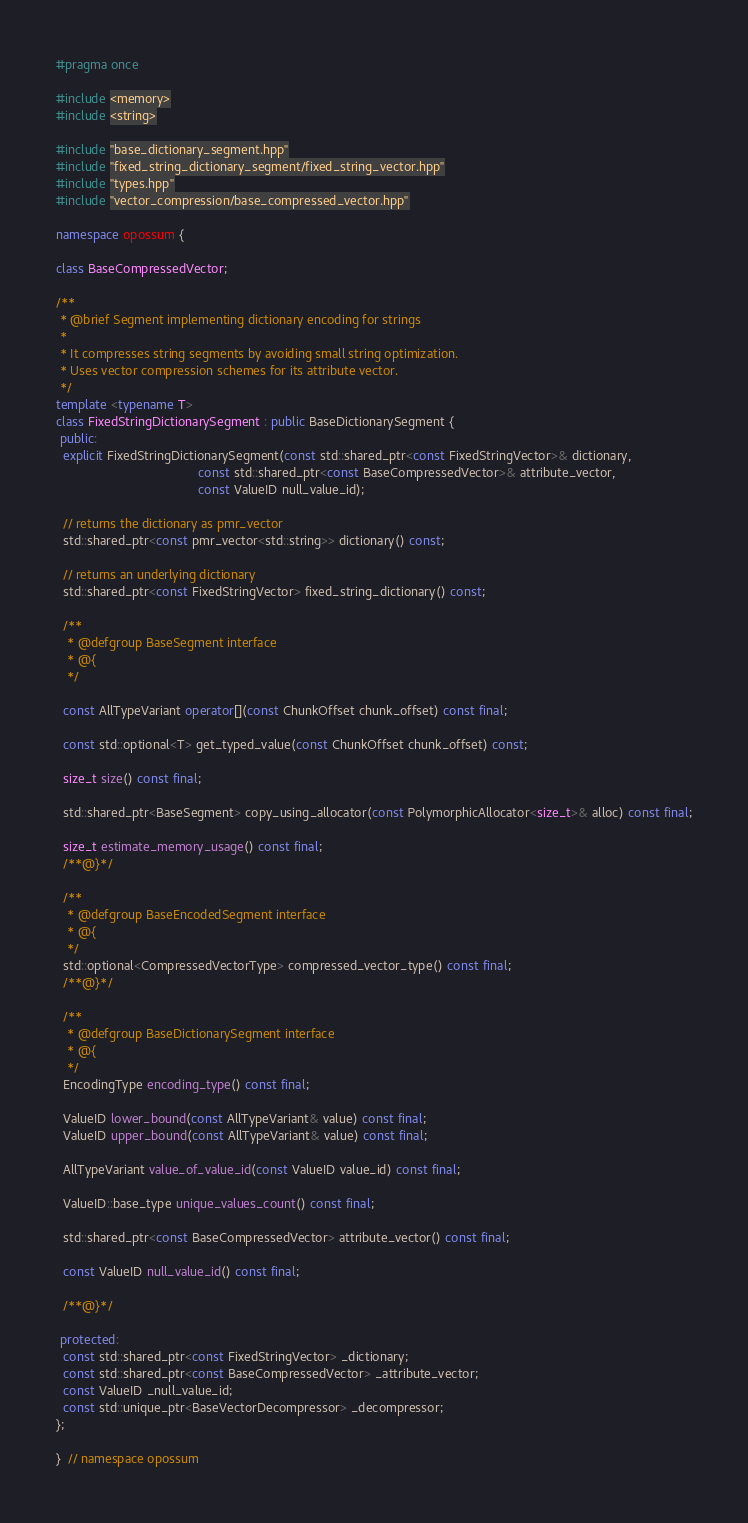Convert code to text. <code><loc_0><loc_0><loc_500><loc_500><_C++_>#pragma once

#include <memory>
#include <string>

#include "base_dictionary_segment.hpp"
#include "fixed_string_dictionary_segment/fixed_string_vector.hpp"
#include "types.hpp"
#include "vector_compression/base_compressed_vector.hpp"

namespace opossum {

class BaseCompressedVector;

/**
 * @brief Segment implementing dictionary encoding for strings
 *
 * It compresses string segments by avoiding small string optimization.
 * Uses vector compression schemes for its attribute vector.
 */
template <typename T>
class FixedStringDictionarySegment : public BaseDictionarySegment {
 public:
  explicit FixedStringDictionarySegment(const std::shared_ptr<const FixedStringVector>& dictionary,
                                        const std::shared_ptr<const BaseCompressedVector>& attribute_vector,
                                        const ValueID null_value_id);

  // returns the dictionary as pmr_vector
  std::shared_ptr<const pmr_vector<std::string>> dictionary() const;

  // returns an underlying dictionary
  std::shared_ptr<const FixedStringVector> fixed_string_dictionary() const;

  /**
   * @defgroup BaseSegment interface
   * @{
   */

  const AllTypeVariant operator[](const ChunkOffset chunk_offset) const final;

  const std::optional<T> get_typed_value(const ChunkOffset chunk_offset) const;

  size_t size() const final;

  std::shared_ptr<BaseSegment> copy_using_allocator(const PolymorphicAllocator<size_t>& alloc) const final;

  size_t estimate_memory_usage() const final;
  /**@}*/

  /**
   * @defgroup BaseEncodedSegment interface
   * @{
   */
  std::optional<CompressedVectorType> compressed_vector_type() const final;
  /**@}*/

  /**
   * @defgroup BaseDictionarySegment interface
   * @{
   */
  EncodingType encoding_type() const final;

  ValueID lower_bound(const AllTypeVariant& value) const final;
  ValueID upper_bound(const AllTypeVariant& value) const final;

  AllTypeVariant value_of_value_id(const ValueID value_id) const final;

  ValueID::base_type unique_values_count() const final;

  std::shared_ptr<const BaseCompressedVector> attribute_vector() const final;

  const ValueID null_value_id() const final;

  /**@}*/

 protected:
  const std::shared_ptr<const FixedStringVector> _dictionary;
  const std::shared_ptr<const BaseCompressedVector> _attribute_vector;
  const ValueID _null_value_id;
  const std::unique_ptr<BaseVectorDecompressor> _decompressor;
};

}  // namespace opossum
</code> 